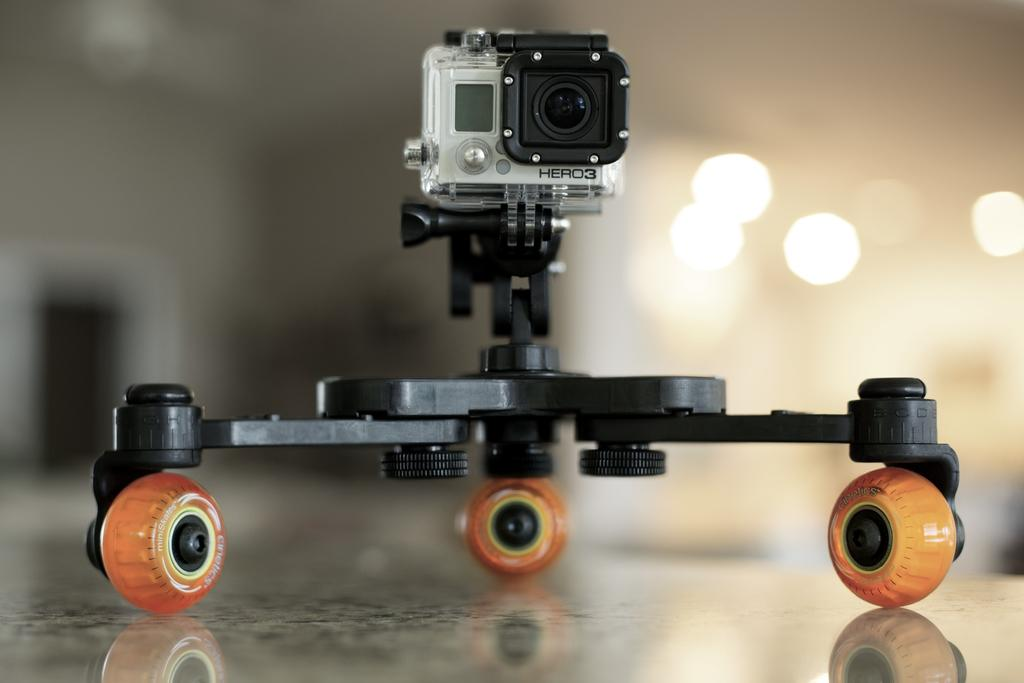What type of electronic device is in the image? There is an electronic gadget in the image. Where is the electronic gadget located? The electronic gadget is placed on the floor. What feature can be seen at the top of the gadget? There is a camera at the top of the gadget. Can you describe the background of the image? The background of the image is blurred. What type of whip is being used to control the electronic gadget in the image? There is no whip present in the image, and the electronic gadget is not being controlled by any external device. 